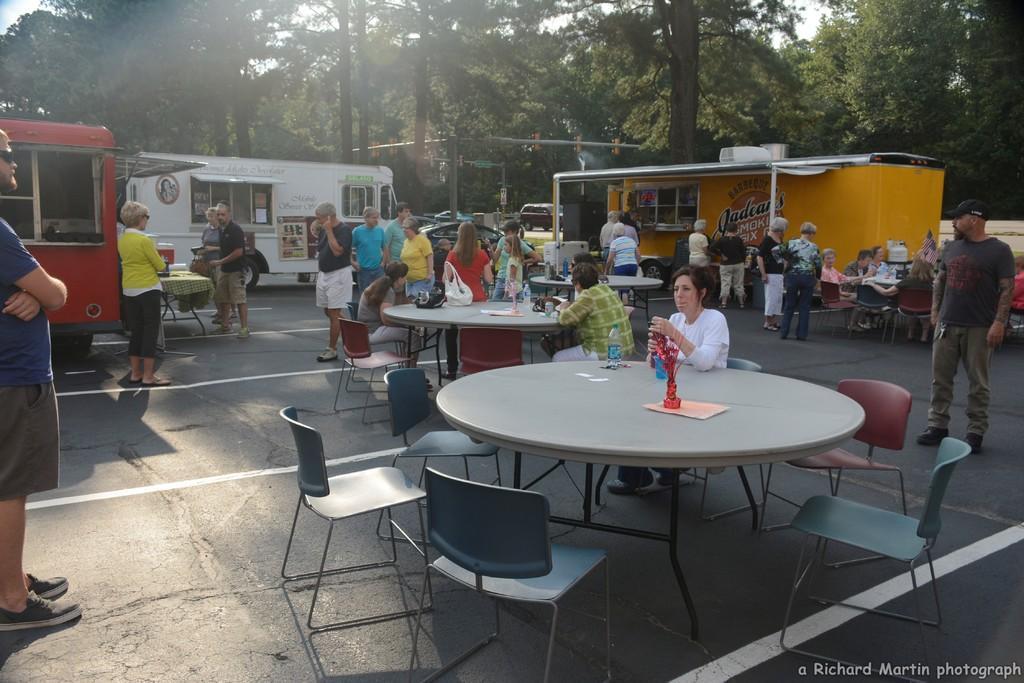Please provide a concise description of this image. There are so much of crowd standing on a road and three food trucks along with tables and chairs. on the other side there are lot of trees. 